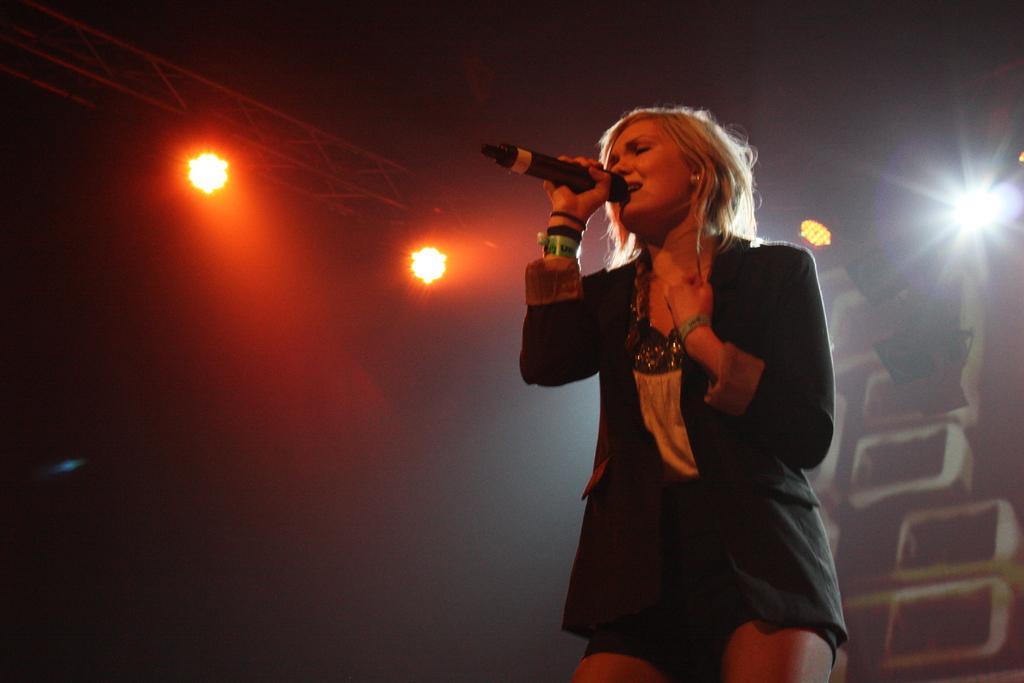Could you give a brief overview of what you see in this image? In the foreground of the picture there is a woman holding a mic and singing. On the left there are focus lights. On the right there are focus light and other objects. 